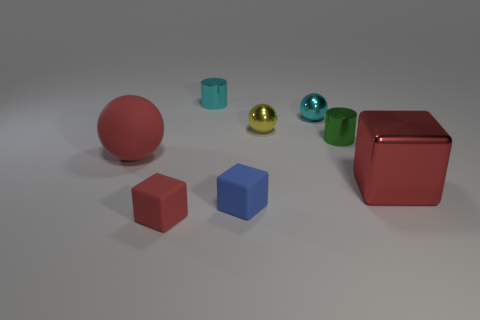Subtract 1 cubes. How many cubes are left? 2 Add 2 big purple metallic things. How many objects exist? 10 Subtract all tiny blocks. How many blocks are left? 1 Subtract all balls. How many objects are left? 5 Add 5 red spheres. How many red spheres exist? 6 Subtract 0 yellow cylinders. How many objects are left? 8 Subtract all small cyan metallic things. Subtract all red metallic things. How many objects are left? 5 Add 1 cylinders. How many cylinders are left? 3 